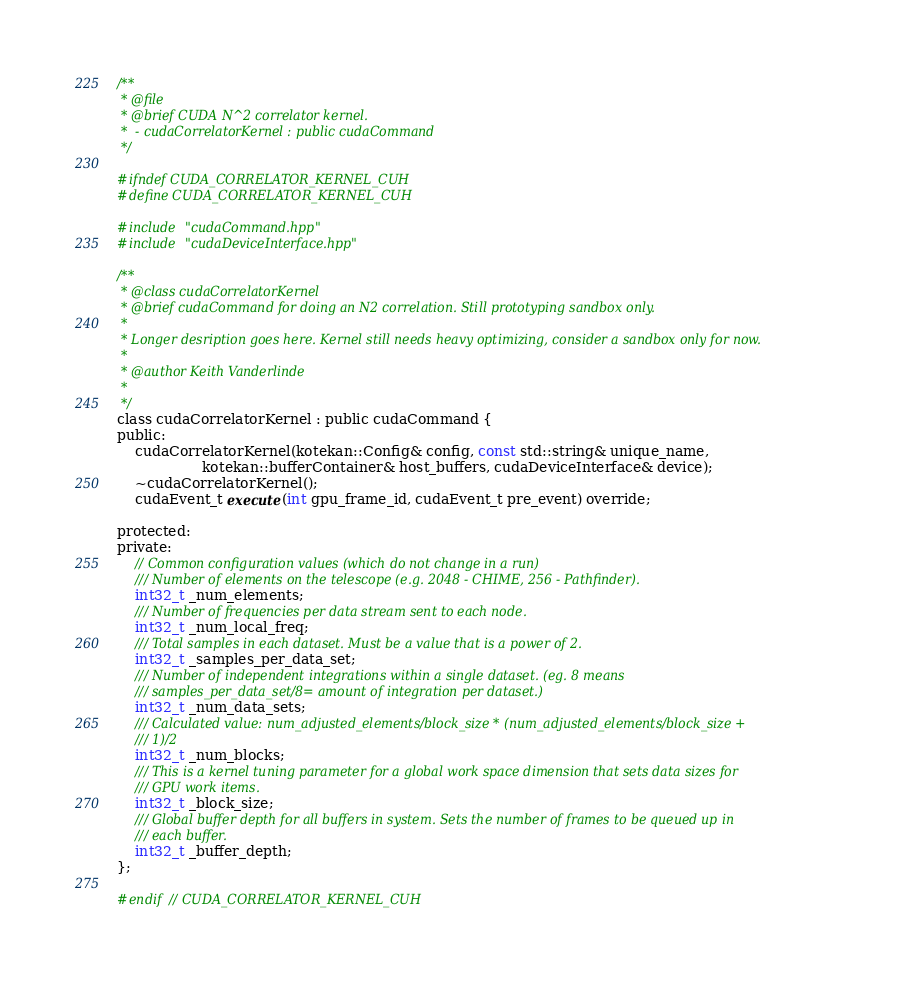Convert code to text. <code><loc_0><loc_0><loc_500><loc_500><_Cuda_>/**
 * @file
 * @brief CUDA N^2 correlator kernel.
 *  - cudaCorrelatorKernel : public cudaCommand
 */

#ifndef CUDA_CORRELATOR_KERNEL_CUH
#define CUDA_CORRELATOR_KERNEL_CUH

#include "cudaCommand.hpp"
#include "cudaDeviceInterface.hpp"

/**
 * @class cudaCorrelatorKernel
 * @brief cudaCommand for doing an N2 correlation. Still prototyping sandbox only.
 *
 * Longer desription goes here. Kernel still needs heavy optimizing, consider a sandbox only for now.
 *
 * @author Keith Vanderlinde
 *
 */
class cudaCorrelatorKernel : public cudaCommand {
public:
    cudaCorrelatorKernel(kotekan::Config& config, const std::string& unique_name,
                   kotekan::bufferContainer& host_buffers, cudaDeviceInterface& device);
    ~cudaCorrelatorKernel();
    cudaEvent_t execute(int gpu_frame_id, cudaEvent_t pre_event) override;

protected:
private:
    // Common configuration values (which do not change in a run)
    /// Number of elements on the telescope (e.g. 2048 - CHIME, 256 - Pathfinder).
    int32_t _num_elements;
    /// Number of frequencies per data stream sent to each node.
    int32_t _num_local_freq;
    /// Total samples in each dataset. Must be a value that is a power of 2.
    int32_t _samples_per_data_set;
    /// Number of independent integrations within a single dataset. (eg. 8 means
    /// samples_per_data_set/8= amount of integration per dataset.)
    int32_t _num_data_sets;
    /// Calculated value: num_adjusted_elements/block_size * (num_adjusted_elements/block_size +
    /// 1)/2
    int32_t _num_blocks;
    /// This is a kernel tuning parameter for a global work space dimension that sets data sizes for
    /// GPU work items.
    int32_t _block_size;
    /// Global buffer depth for all buffers in system. Sets the number of frames to be queued up in
    /// each buffer.
    int32_t _buffer_depth;
};

#endif // CUDA_CORRELATOR_KERNEL_CUH
</code> 